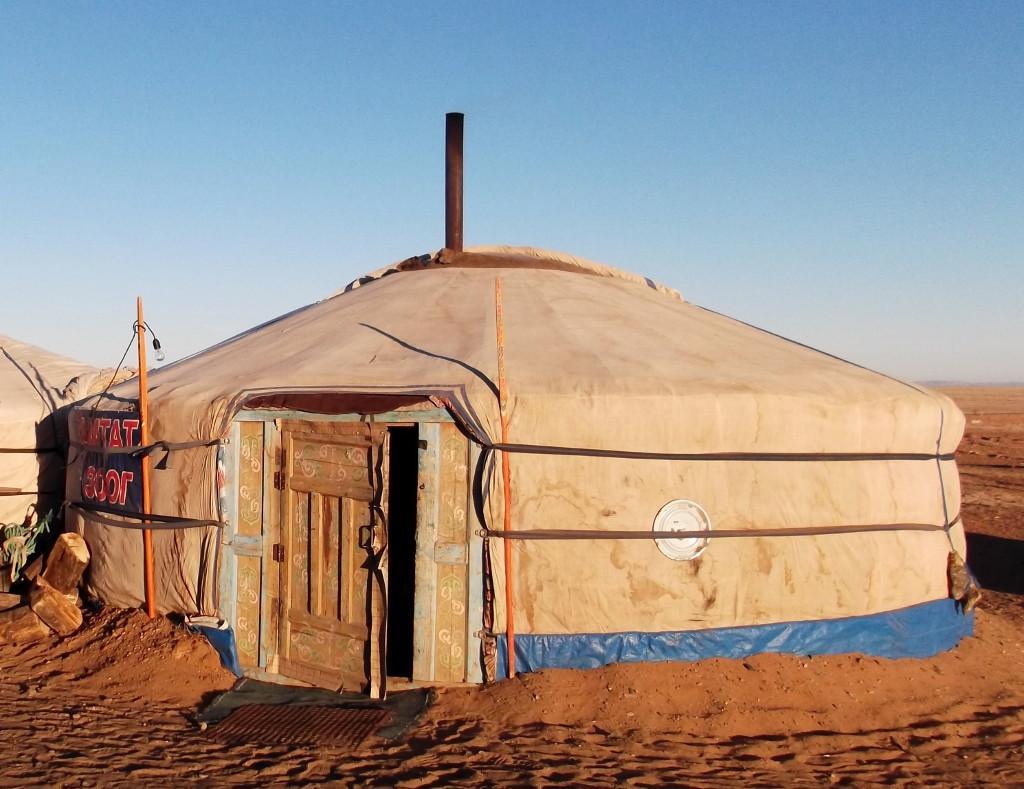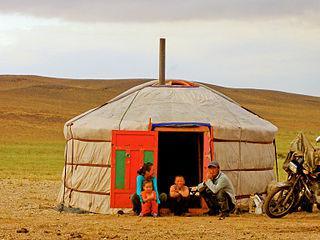The first image is the image on the left, the second image is the image on the right. Considering the images on both sides, is "At least one hut is not yet wrapped in fabric." valid? Answer yes or no. No. The first image is the image on the left, the second image is the image on the right. Analyze the images presented: Is the assertion "homes are in the construction phase" valid? Answer yes or no. No. 